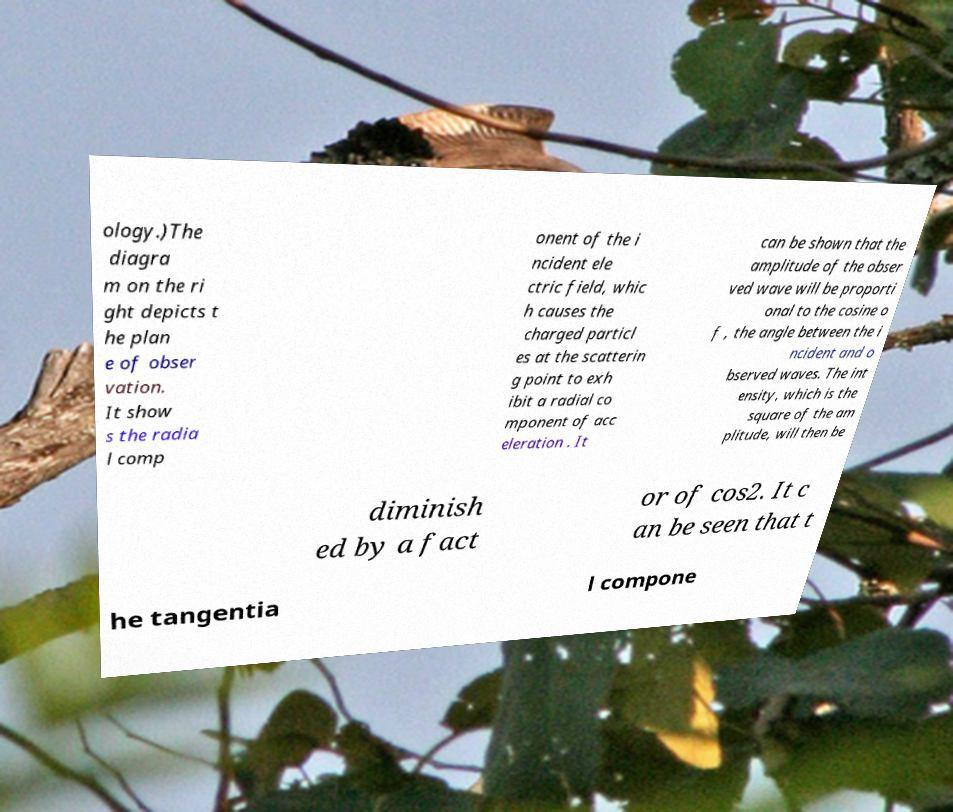Please identify and transcribe the text found in this image. ology.)The diagra m on the ri ght depicts t he plan e of obser vation. It show s the radia l comp onent of the i ncident ele ctric field, whic h causes the charged particl es at the scatterin g point to exh ibit a radial co mponent of acc eleration . It can be shown that the amplitude of the obser ved wave will be proporti onal to the cosine o f , the angle between the i ncident and o bserved waves. The int ensity, which is the square of the am plitude, will then be diminish ed by a fact or of cos2. It c an be seen that t he tangentia l compone 